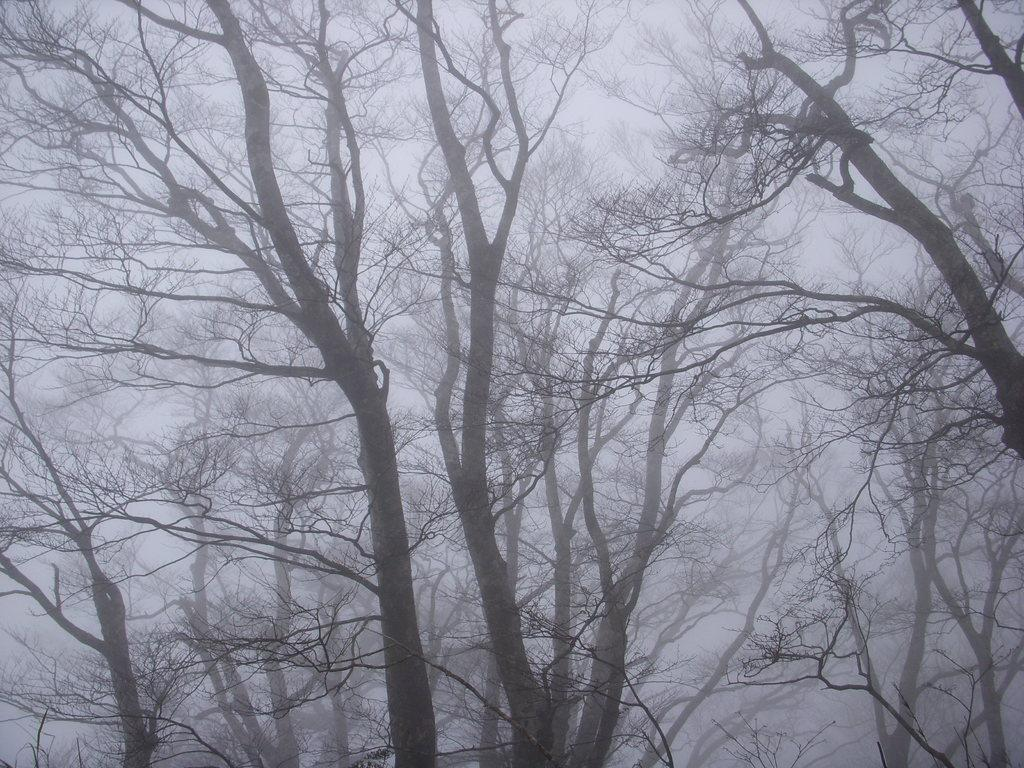What is the primary feature of the landscape in the image? There are many trees in the image. How would you describe the overall appearance of the image? The image is covered with fog. What type of hands can be seen reaching out from the fog in the image? There are no hands visible in the image; it is covered with fog and primarily features trees. 